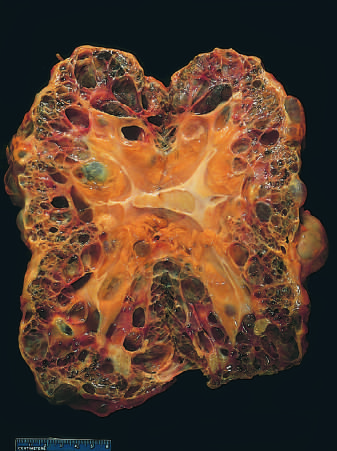what is shown for scale?
Answer the question using a single word or phrase. Centimeter rule 